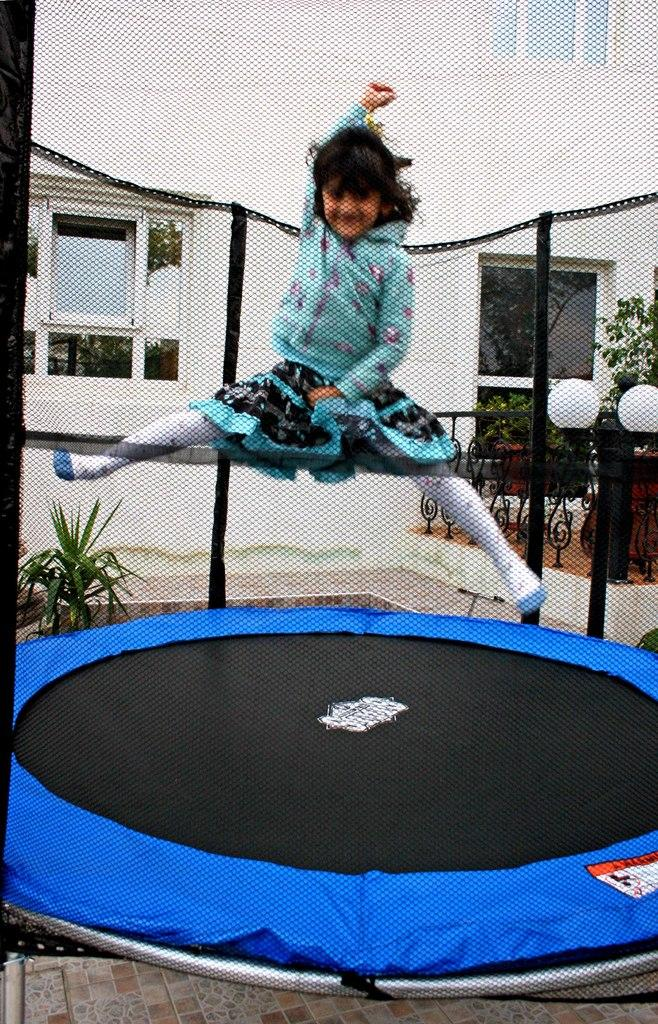Who is the main subject in the image? There is a girl in the image. What is the girl wearing? The girl is wearing clothes. What is the girl doing in the image? The girl is jumping. What can be seen in the background of the image? There is a net, a footpath, a light pole, a plant, a fence, and a building with a window in the image. What type of powder is being used by the girl in the image? There is no powder visible in the image; the girl is simply jumping. What is the texture of the activity the girl is participating in? The activity of jumping does not have a specific texture, as it is a physical movement. 